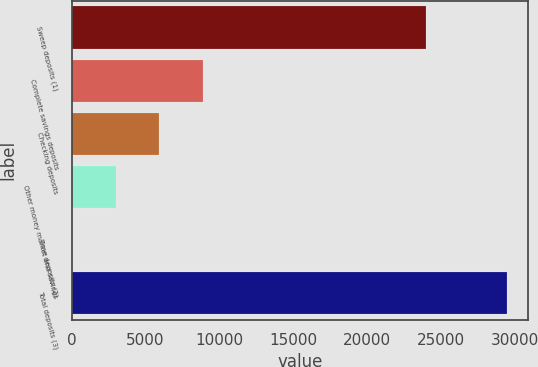Convert chart. <chart><loc_0><loc_0><loc_500><loc_500><bar_chart><fcel>Sweep deposits (1)<fcel>Complete savings deposits<fcel>Checking deposits<fcel>Other money market and savings<fcel>Time deposits (2)<fcel>Total deposits (3)<nl><fcel>24018<fcel>8860.8<fcel>5920.2<fcel>2979.6<fcel>39<fcel>29445<nl></chart> 